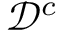<formula> <loc_0><loc_0><loc_500><loc_500>\mathcal { D } ^ { c }</formula> 